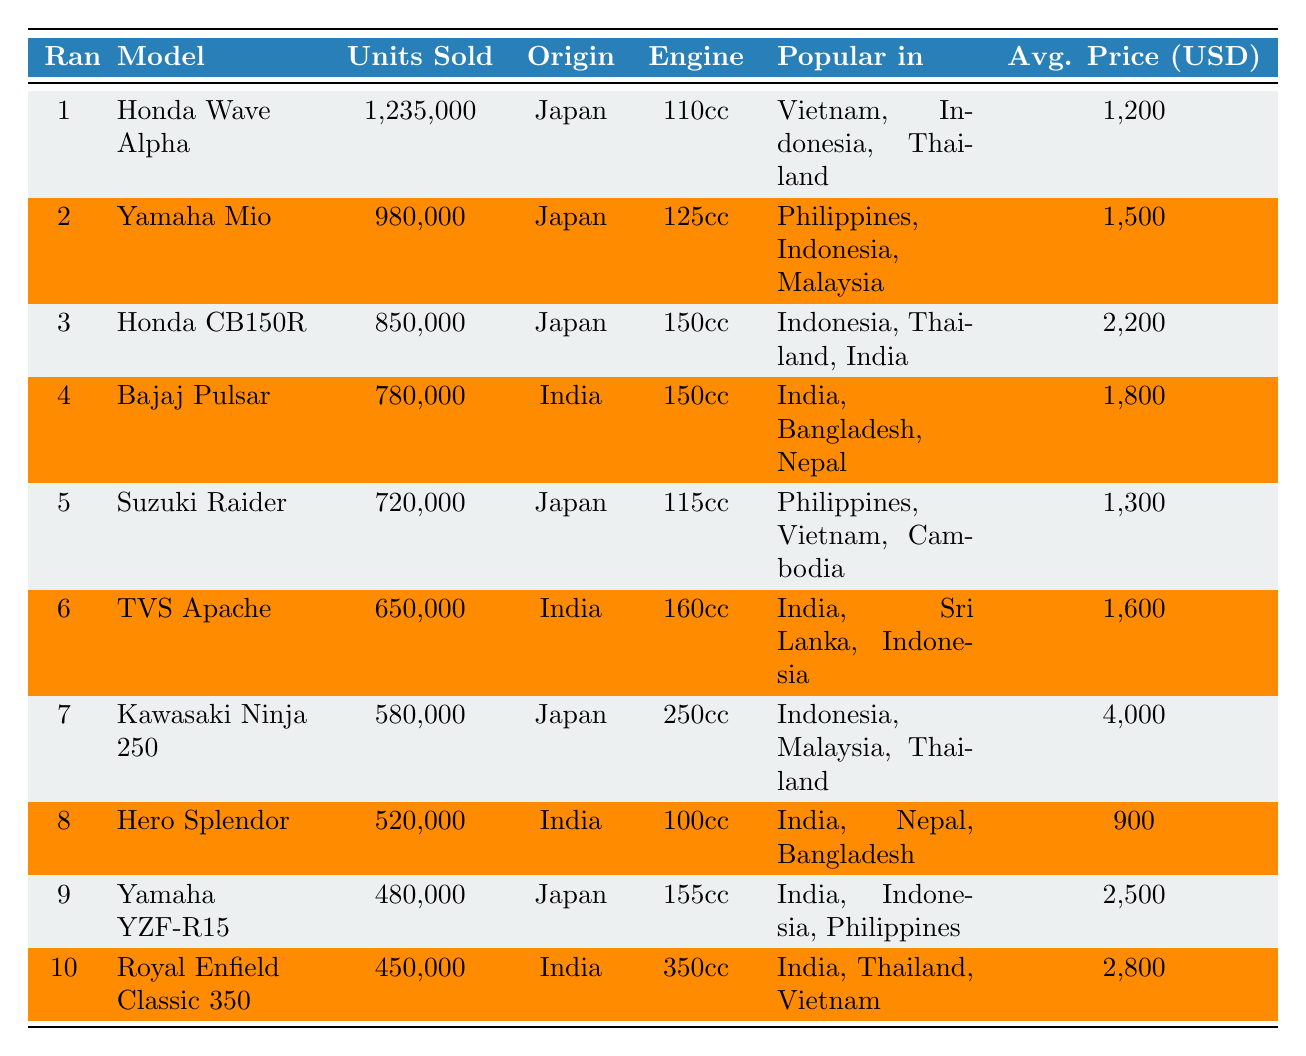What is the best-selling motorcycle model in Asia for 2022? The table shows that "Honda Wave Alpha" is ranked 1st, with the highest units sold of 1,235,000.
Answer: Honda Wave Alpha How many units of Yamaha Mio were sold in 2022? The table indicates that Yamaha Mio sold 980,000 units, as listed in the "Units Sold" column.
Answer: 980,000 Which motorcycle model has the largest engine capacity? By reviewing the "Engine Capacity" column, "Royal Enfield Classic 350" has the largest engine capacity of 350cc.
Answer: Royal Enfield Classic 350 Is Honda CB150R more popular in India or Thailand? The table states that Honda CB150R is popular in Indonesia, Thailand, and India. Since it lists Thailand first, it is more popular in Thailand than India.
Answer: Yes, more popular in Thailand What is the average price of the top three best-selling motorcycle models? The average price can be calculated by summing the average prices of the top three models: (1200 + 1500 + 2200) = 4900, and then dividing by 3, which equals 1633.33.
Answer: 1633.33 How many more units were sold of Honda Wave Alpha compared to Bajaj Pulsar? Honda Wave Alpha sold 1,235,000 units and Bajaj Pulsar sold 780,000 units. The difference is calculated as 1,235,000 - 780,000 = 455,000.
Answer: 455,000 Which country has the most motorcycle models listed in the top 10? Upon examining the "Country of Origin" column, Japan appears 5 times (for models 1, 2, 3, 5, and 7) while India appears 4 times (for models 4, 6, 8, and 10), indicating Japan has the most.
Answer: Japan What is the total number of units sold for all the motorcycles in the list? The total can be found by summing all units sold: 1,235,000 + 980,000 + 850,000 + 780,000 + 720,000 + 650,000 + 580,000 + 520,000 + 480,000 + 450,000 = 6,185,000.
Answer: 6,185,000 Which model is the cheapest among the top 10 best-sellers? Checking the "Average Price" column, the cheapest model is the Hero Splendor listed at $900.
Answer: Hero Splendor Does any model from India have a higher average price than the Honda CB150R? The average price of Honda CB150R is $2,200. The Indian models are Bajaj Pulsar ($1,800), TVS Apache ($1,600), Hero Splendor ($900), and Royal Enfield Classic 350 ($2,800). Comparing these, the Royal Enfield Classic 350 has a higher average price than Honda CB150R.
Answer: Yes, Royal Enfield Classic 350 